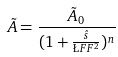<formula> <loc_0><loc_0><loc_500><loc_500>\tilde { A } = \frac { \tilde { A } _ { 0 } } { ( 1 + \frac { \hat { s } } { \L F F ^ { 2 } } ) ^ { n } }</formula> 